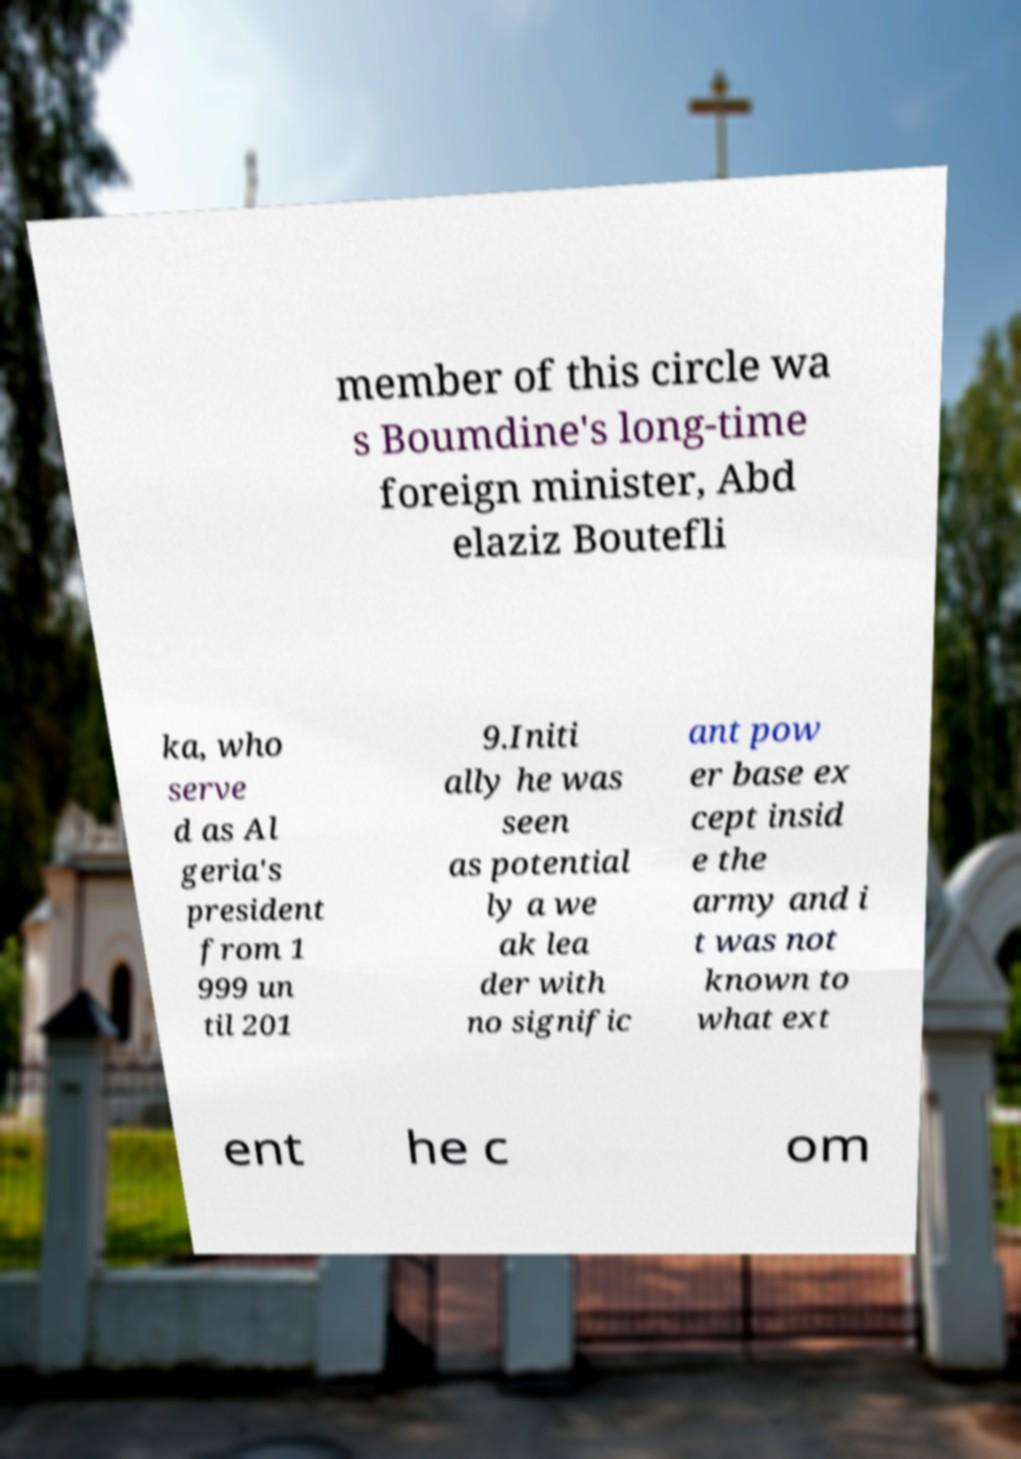There's text embedded in this image that I need extracted. Can you transcribe it verbatim? member of this circle wa s Boumdine's long-time foreign minister, Abd elaziz Boutefli ka, who serve d as Al geria's president from 1 999 un til 201 9.Initi ally he was seen as potential ly a we ak lea der with no signific ant pow er base ex cept insid e the army and i t was not known to what ext ent he c om 